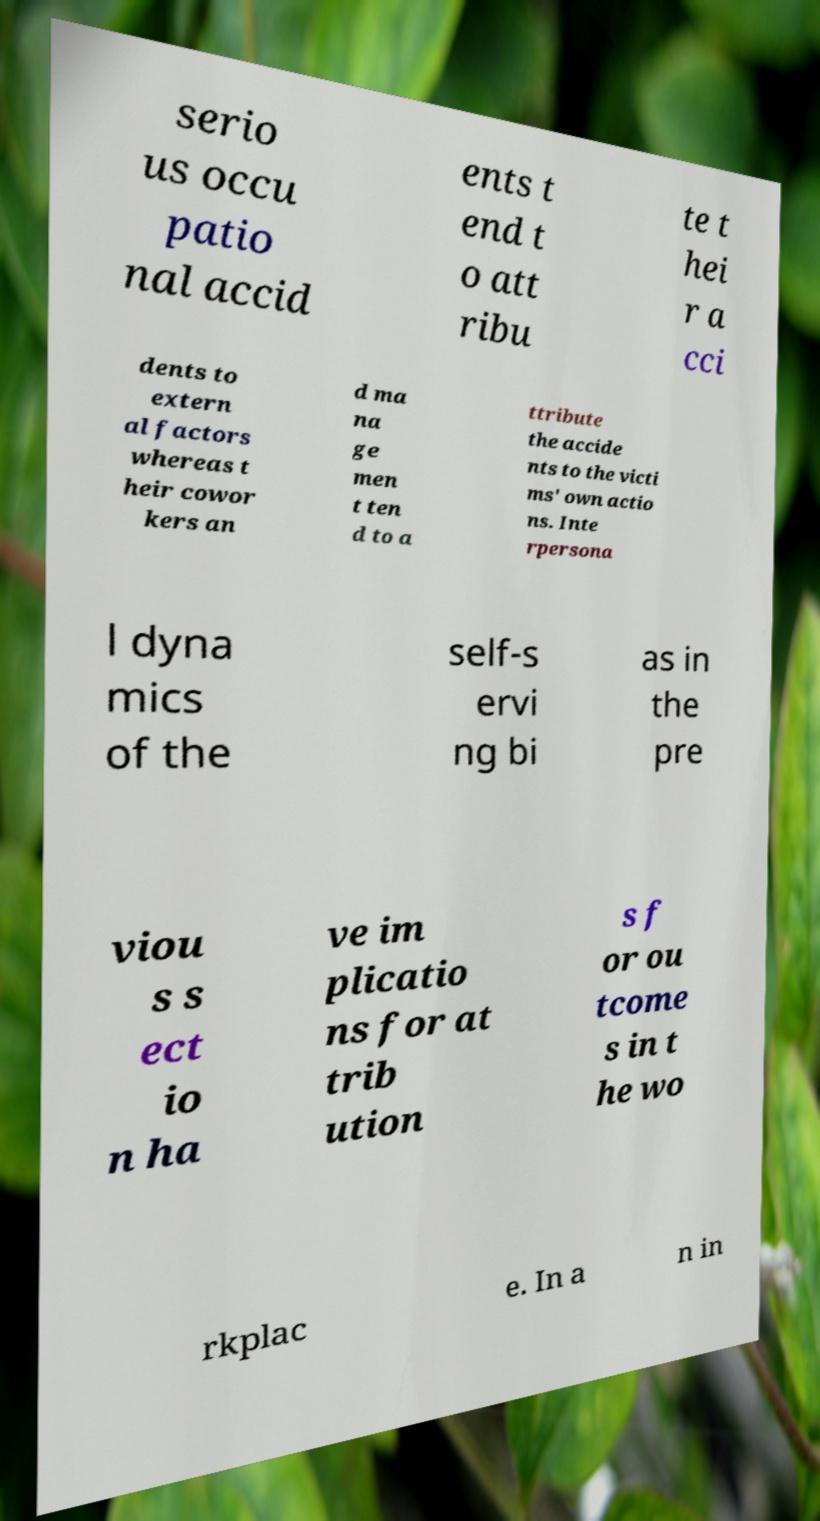I need the written content from this picture converted into text. Can you do that? serio us occu patio nal accid ents t end t o att ribu te t hei r a cci dents to extern al factors whereas t heir cowor kers an d ma na ge men t ten d to a ttribute the accide nts to the victi ms' own actio ns. Inte rpersona l dyna mics of the self-s ervi ng bi as in the pre viou s s ect io n ha ve im plicatio ns for at trib ution s f or ou tcome s in t he wo rkplac e. In a n in 